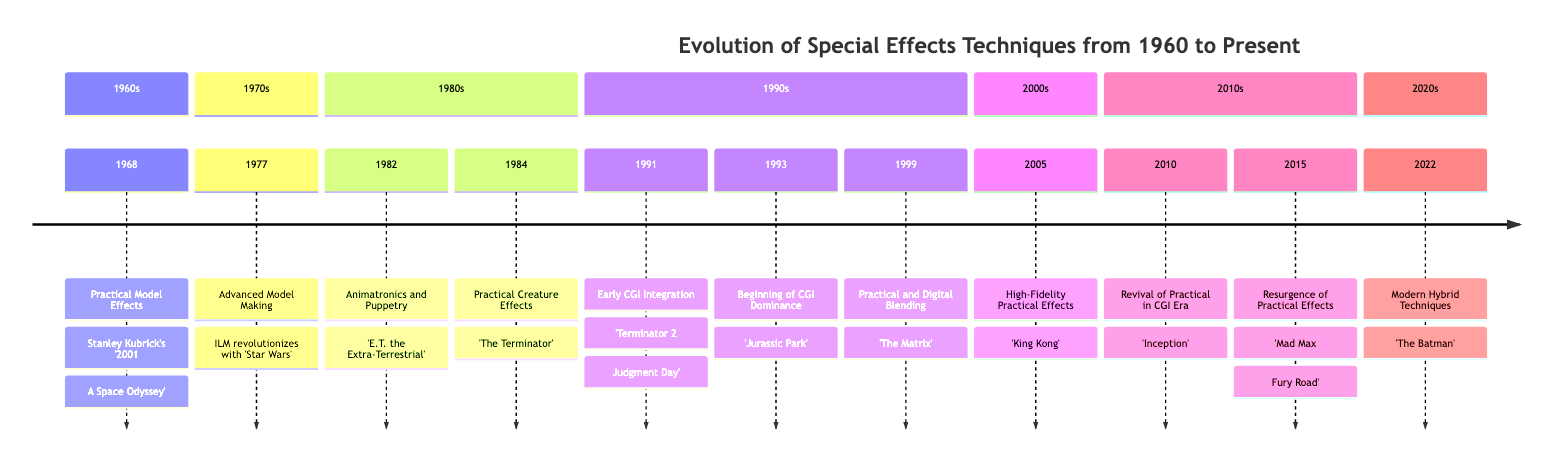What year did the event 'Practical Model Effects' occur? By looking at the diagram, we can see that 'Practical Model Effects' is listed under the 1960s section, and the associated year is 1968.
Answer: 1968 How many events are listed in the 1980s section? In the 1980s section, there are two events: 'Animatronics and Puppetry' in 1982 and 'Practical Creature Effects' in 1984. Counting these, we find that the total is 2.
Answer: 2 Which film is associated with the year 1993? The event listed for the year 1993 is 'Beginning of CGI Dominance', and the film associated with this event is 'Jurassic Park'. By directly referencing this information in the diagram, we identify the film correctly.
Answer: Jurassic Park What significant technique was introduced in 'Terminator 2: Judgment Day'? The diagram indicates that 'Terminator 2: Judgment Day' features 'Early CGI Integration'. This suggests the combination of practical effects with early CGI, which is the standout technique in this entry.
Answer: Early CGI Integration In which decade did the 'Resurgence of Practical Effects' happen? Looking at the events, 'Resurgence of Practical Effects' occurs in the year 2015, which is listed under the 2010s section of the diagram. Thus, the decade is the 2010s.
Answer: 2010s What notable effect is highlighted in 'Mad Max: Fury Road'? The entry for 'Mad Max: Fury Road' states it highlights a return to 'practical stunts and pyrotechnics', pointing out the main aspects of its special effects.
Answer: Practical stunts and pyrotechnics Which studio was involved in the special effects for 'The Terminator'? According to the diagram, 'The Terminator' features work from Stan Winston Studio, as highlighted in the description of 'Practical Creature Effects'.
Answer: Stan Winston Studio Which film from the 2000s utilized a mix of practical miniature sets and CGI? The description under the 2005 event 'High-Fidelity Practical Effects' indicates that 'King Kong' used both practical miniature sets and CGI, defining its notable approach to special effects.
Answer: King Kong What is the main focus of the effects in 'Inception'? The diagram specifies that 'Inception' emphasizes 'practical effects like rotating sets and large-scale models', making this the focal point of its effects.
Answer: Practical effects like rotating sets and large-scale models 